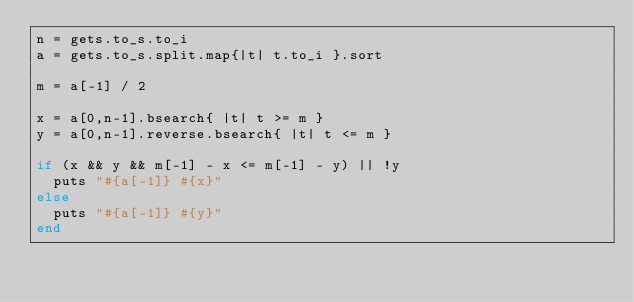<code> <loc_0><loc_0><loc_500><loc_500><_Ruby_>n = gets.to_s.to_i
a = gets.to_s.split.map{|t| t.to_i }.sort

m = a[-1] / 2

x = a[0,n-1].bsearch{ |t| t >= m }
y = a[0,n-1].reverse.bsearch{ |t| t <= m }

if (x && y && m[-1] - x <= m[-1] - y) || !y
  puts "#{a[-1]} #{x}"
else
  puts "#{a[-1]} #{y}"
end</code> 